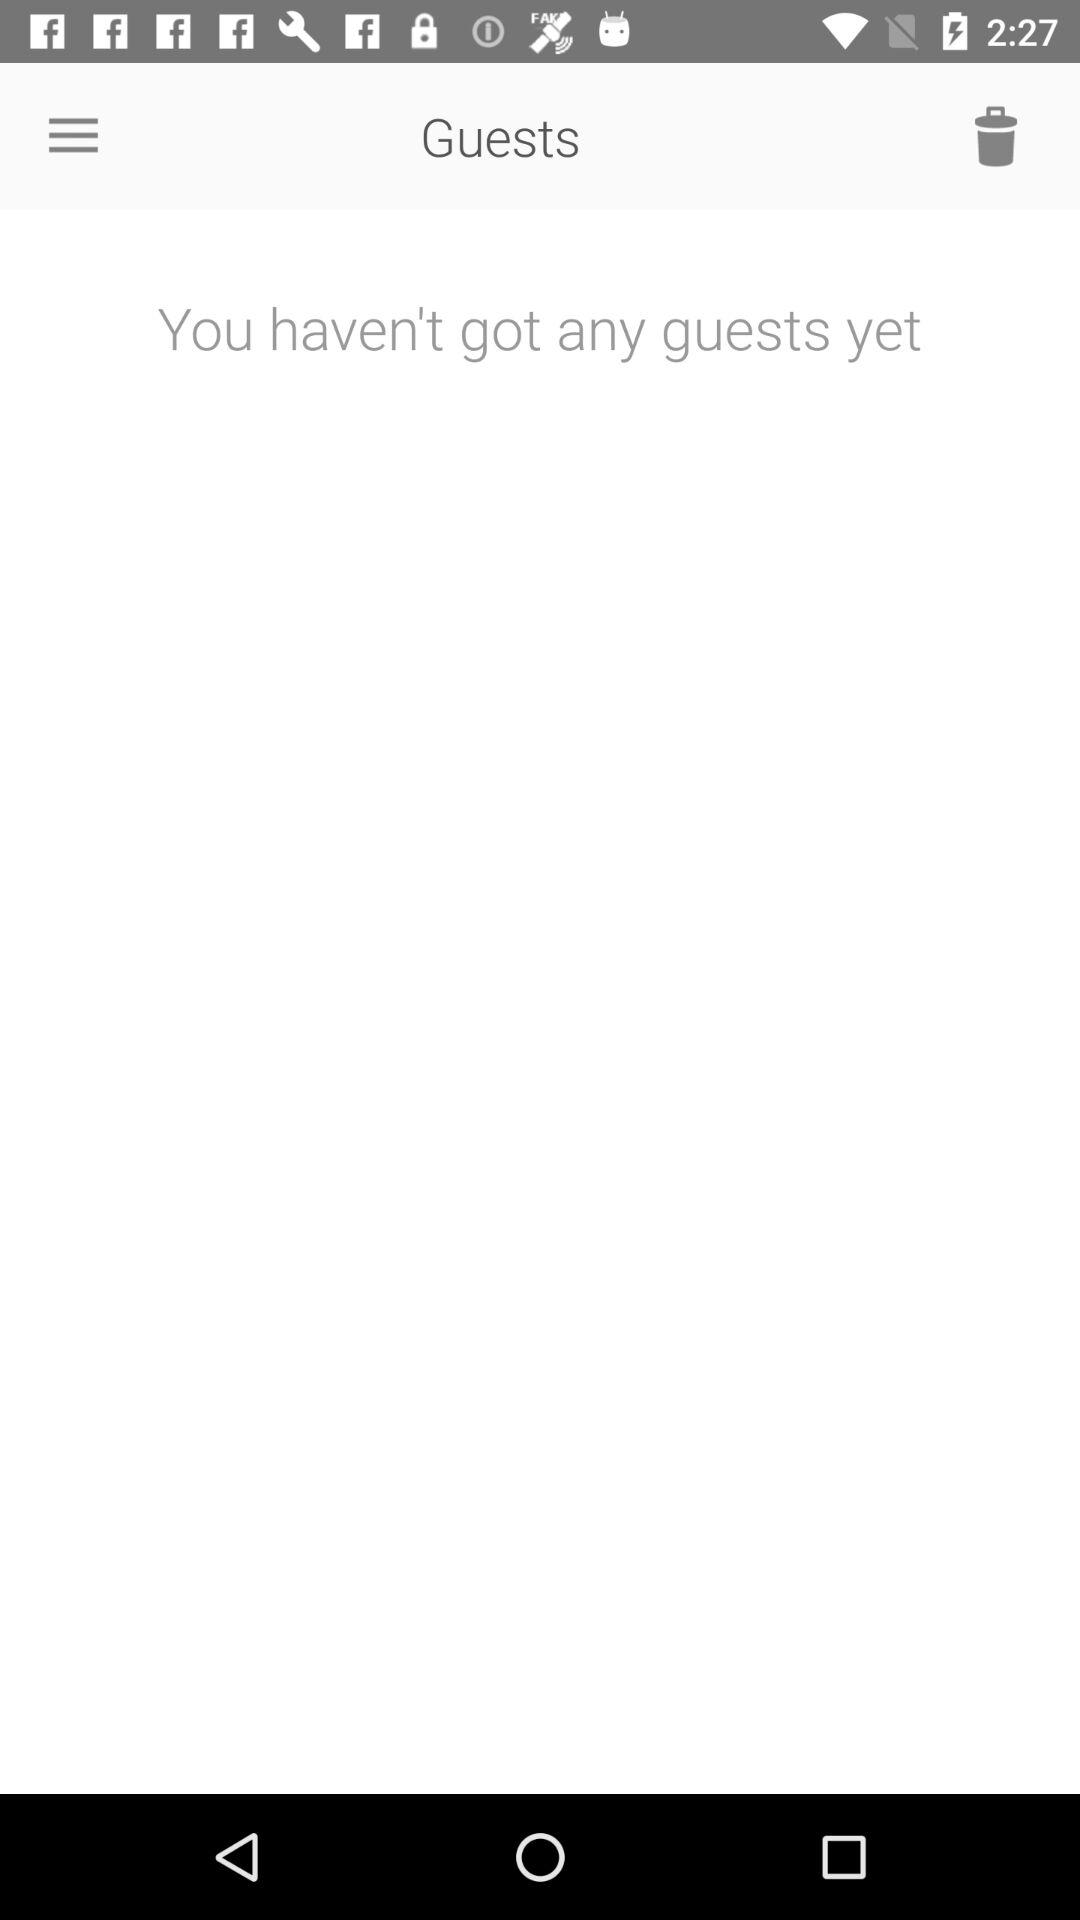How many guests are there?
Answer the question using a single word or phrase. 0 